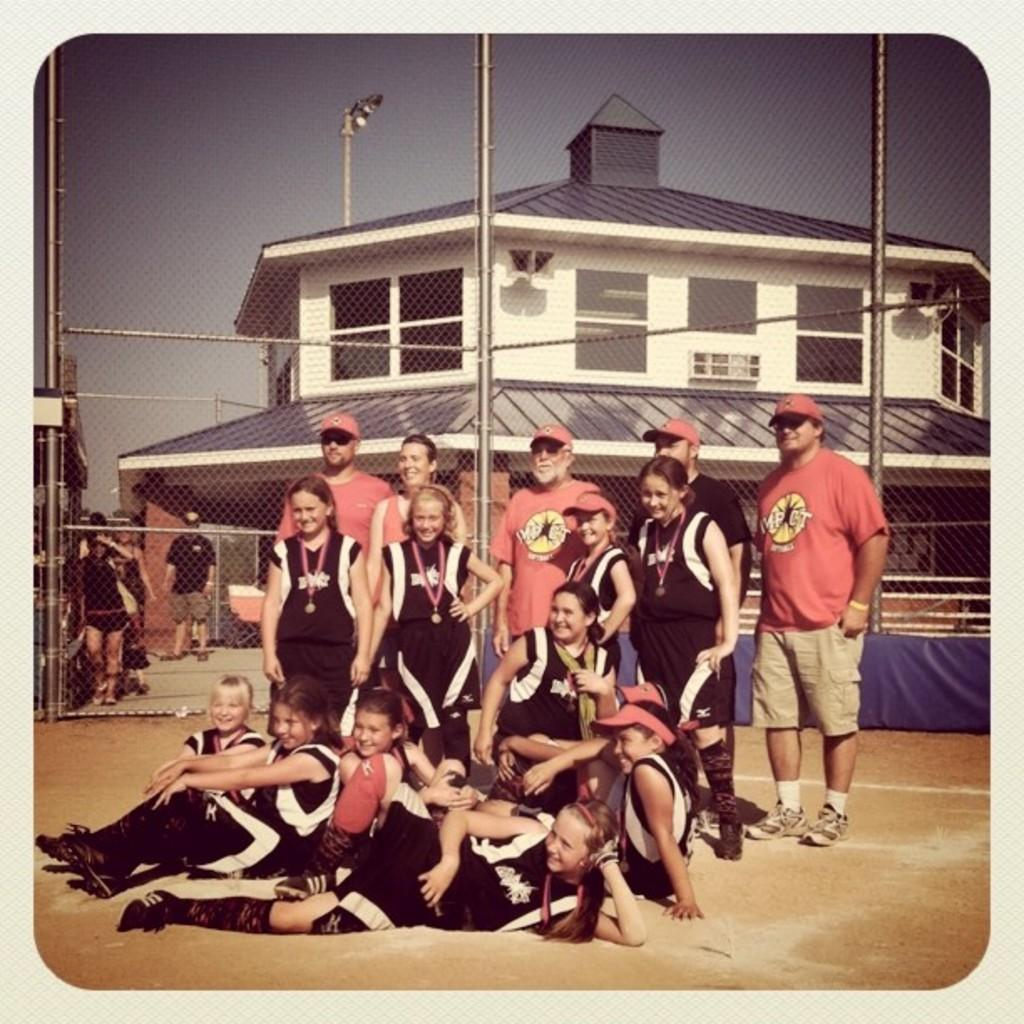What are the little girls doing in the image? The little girls are sitting on the ground in the image. What are the people in the image doing? The people are standing and looking at someone in the image. What can be seen in the background of the image? There is a house and a gate in the background of the image. What type of frogs can be seen playing chess on the farm in the image? There are no frogs or chess games present in the image; it features little girls sitting on the ground and people standing nearby. 